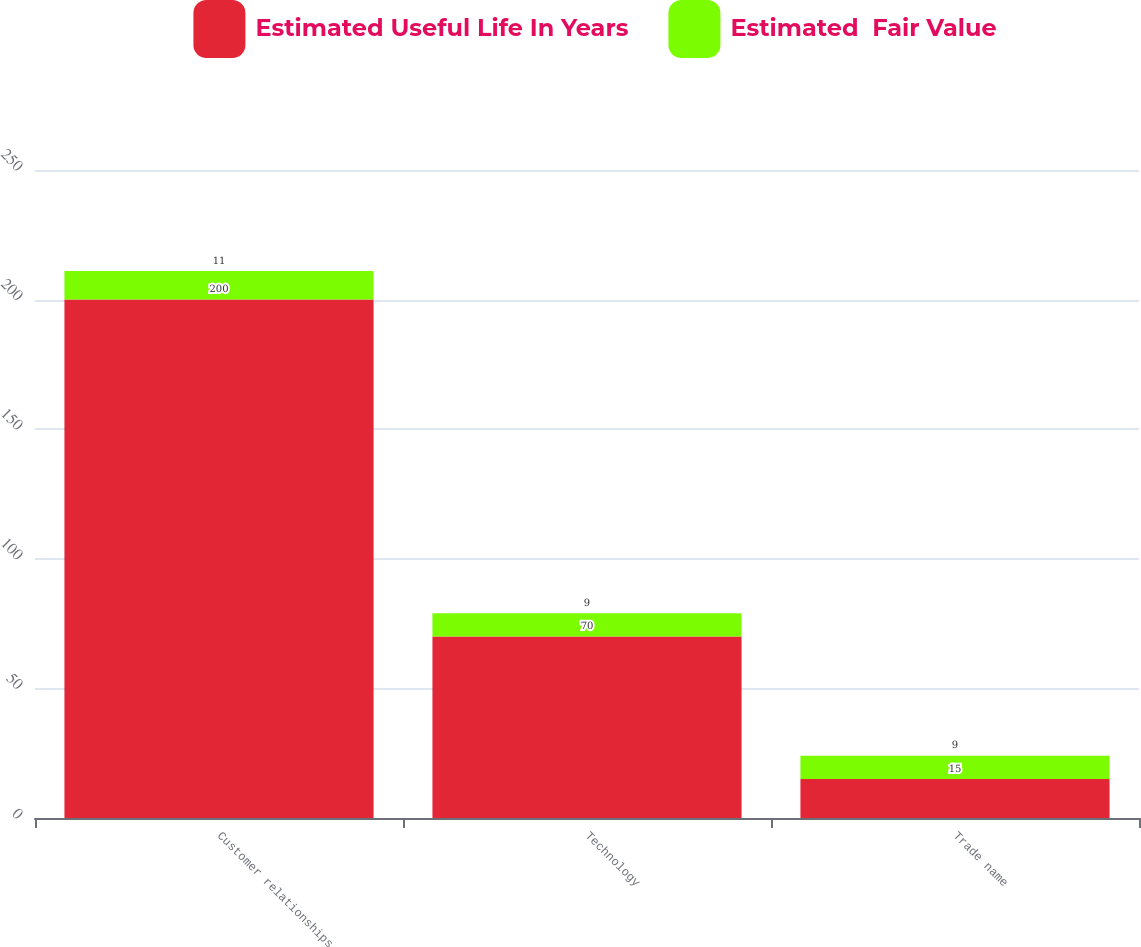<chart> <loc_0><loc_0><loc_500><loc_500><stacked_bar_chart><ecel><fcel>Customer relationships<fcel>Technology<fcel>Trade name<nl><fcel>Estimated Useful Life In Years<fcel>200<fcel>70<fcel>15<nl><fcel>Estimated  Fair Value<fcel>11<fcel>9<fcel>9<nl></chart> 